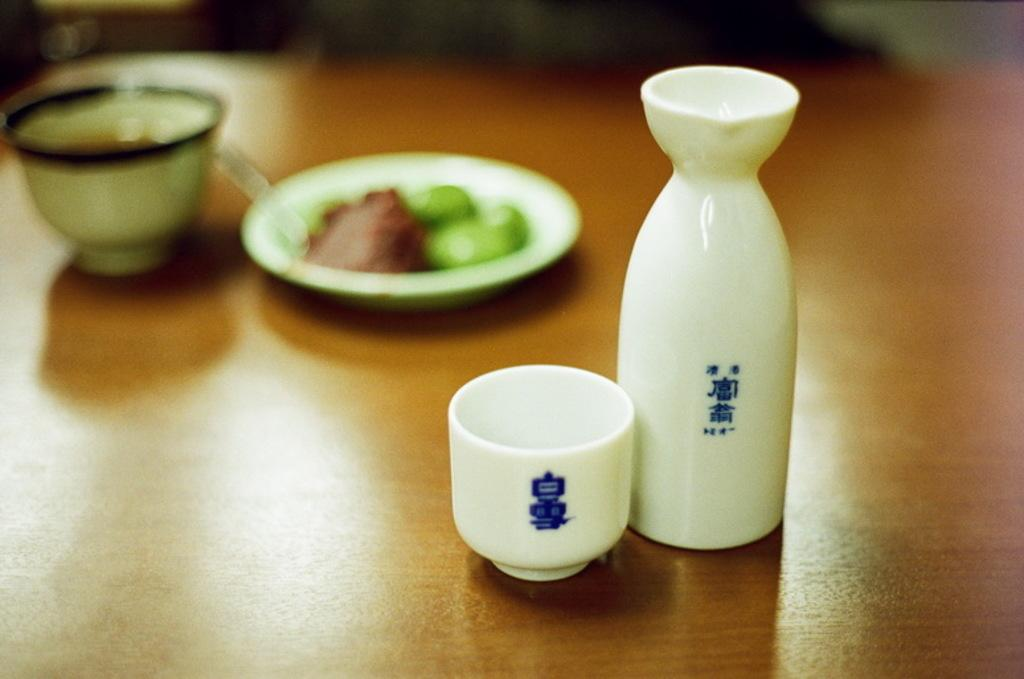What type of objects can be seen on the table in the image? There are two ceramic objects in the image. Where are the ceramic objects located? The ceramic objects are placed on a table. Can you describe the background of the image? The background of the image is blurred. What type of thunder can be heard in the image? There is no sound, including thunder, present in the image, as it is a still photograph. 